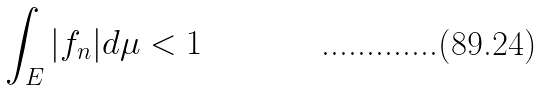Convert formula to latex. <formula><loc_0><loc_0><loc_500><loc_500>\int _ { E } | f _ { n } | d \mu < 1</formula> 